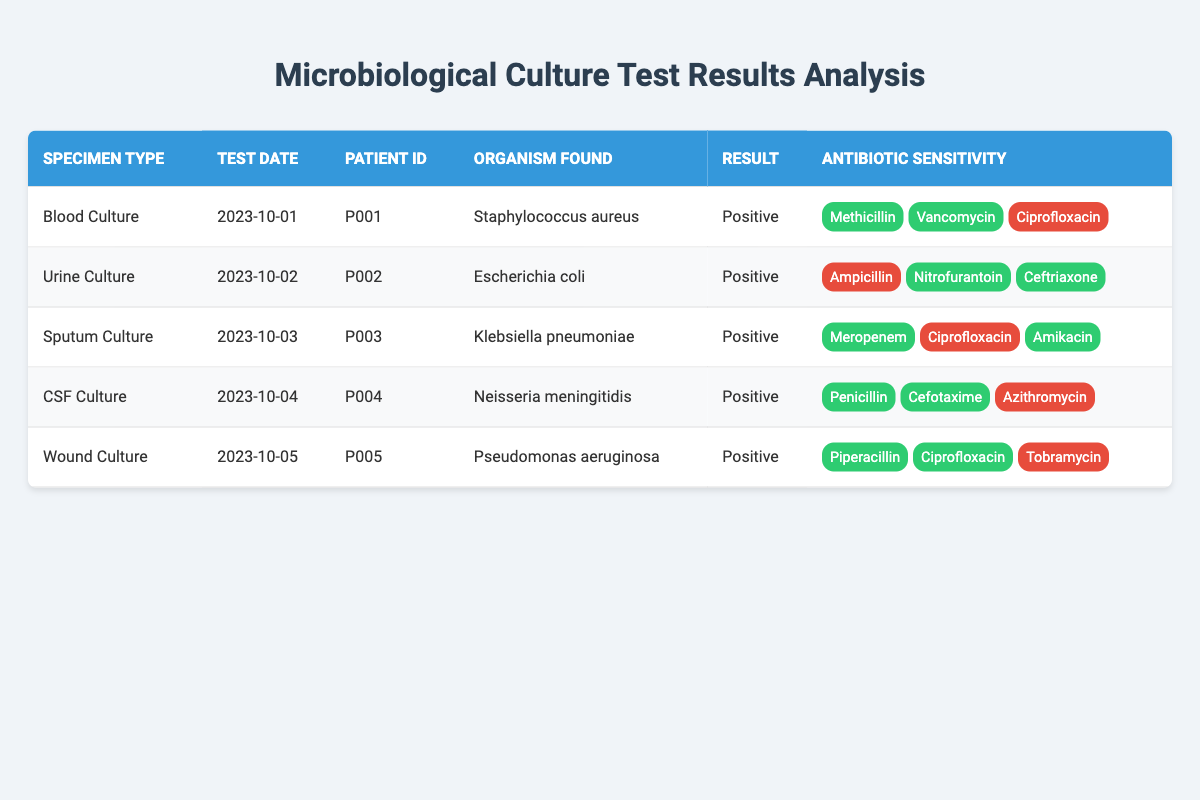What organism was found in the Blood Culture? The table indicates the organism found in the Blood Culture row, which is Staphylococcus aureus.
Answer: Staphylococcus aureus Which specimen type showed resistance to Ciprofloxacin? In the table, the Urine Culture, Sputum Culture, and Wound Culture rows indicate resistance to Ciprofloxacin.
Answer: Urine Culture, Sputum Culture, Wound Culture How many specimens had a Positive result? All rows in the table show a result of Positive for their respective specimen types, totaling 5 specimens.
Answer: 5 Was Neisseria meningitidis resistant to Azithromycin? In the CSF Culture row of the table, the antibiotic sensitivity shows that Neisseria meningitidis is resistant to Azithromycin.
Answer: Yes Which specimen type had the highest number of sensitive antibiotics? The Wound Culture row shows that Pseudomonas aeruginosa was sensitive to Piperacillin and Ciprofloxacin, totaling 2 sensitive antibiotics, while all other rows have a maximum of 2 sensitive antibiotics as well. Hence, there is no single specimen type with more than 2 sensitive antibiotics.
Answer: No specimen type had more What is the average number of sensitive antibiotics across all specimens? Each specimen type has a different number of sensitive antibiotics: Blood Culture (2), Urine Culture (2), Sputum Culture (2), CSF Culture (2), and Wound Culture (2). The average is calculated as follows: (2 + 2 + 2 + 2 + 2) / 5 = 2.
Answer: 2 Did any patient have a culture with a resistant organism? Yes, the table shows that multiple organisms had resistant antibiotics, indicating that at least one organism was found to resist some antibiotics, for example, Escherichia coli in the Urine Culture had a resistant result for Ampicillin.
Answer: Yes Among the organisms found, which one had resistance in two different antibiotics? In the Urine Culture, Escherichia coli shows resistance to Ampicillin and in the Wound Culture, Pseudomonas aeruginosa is resistant to Tobramycin. Therefore, both had resistance in two different antibiotics.
Answer: Escherichia coli and Pseudomonas aeruginosa 